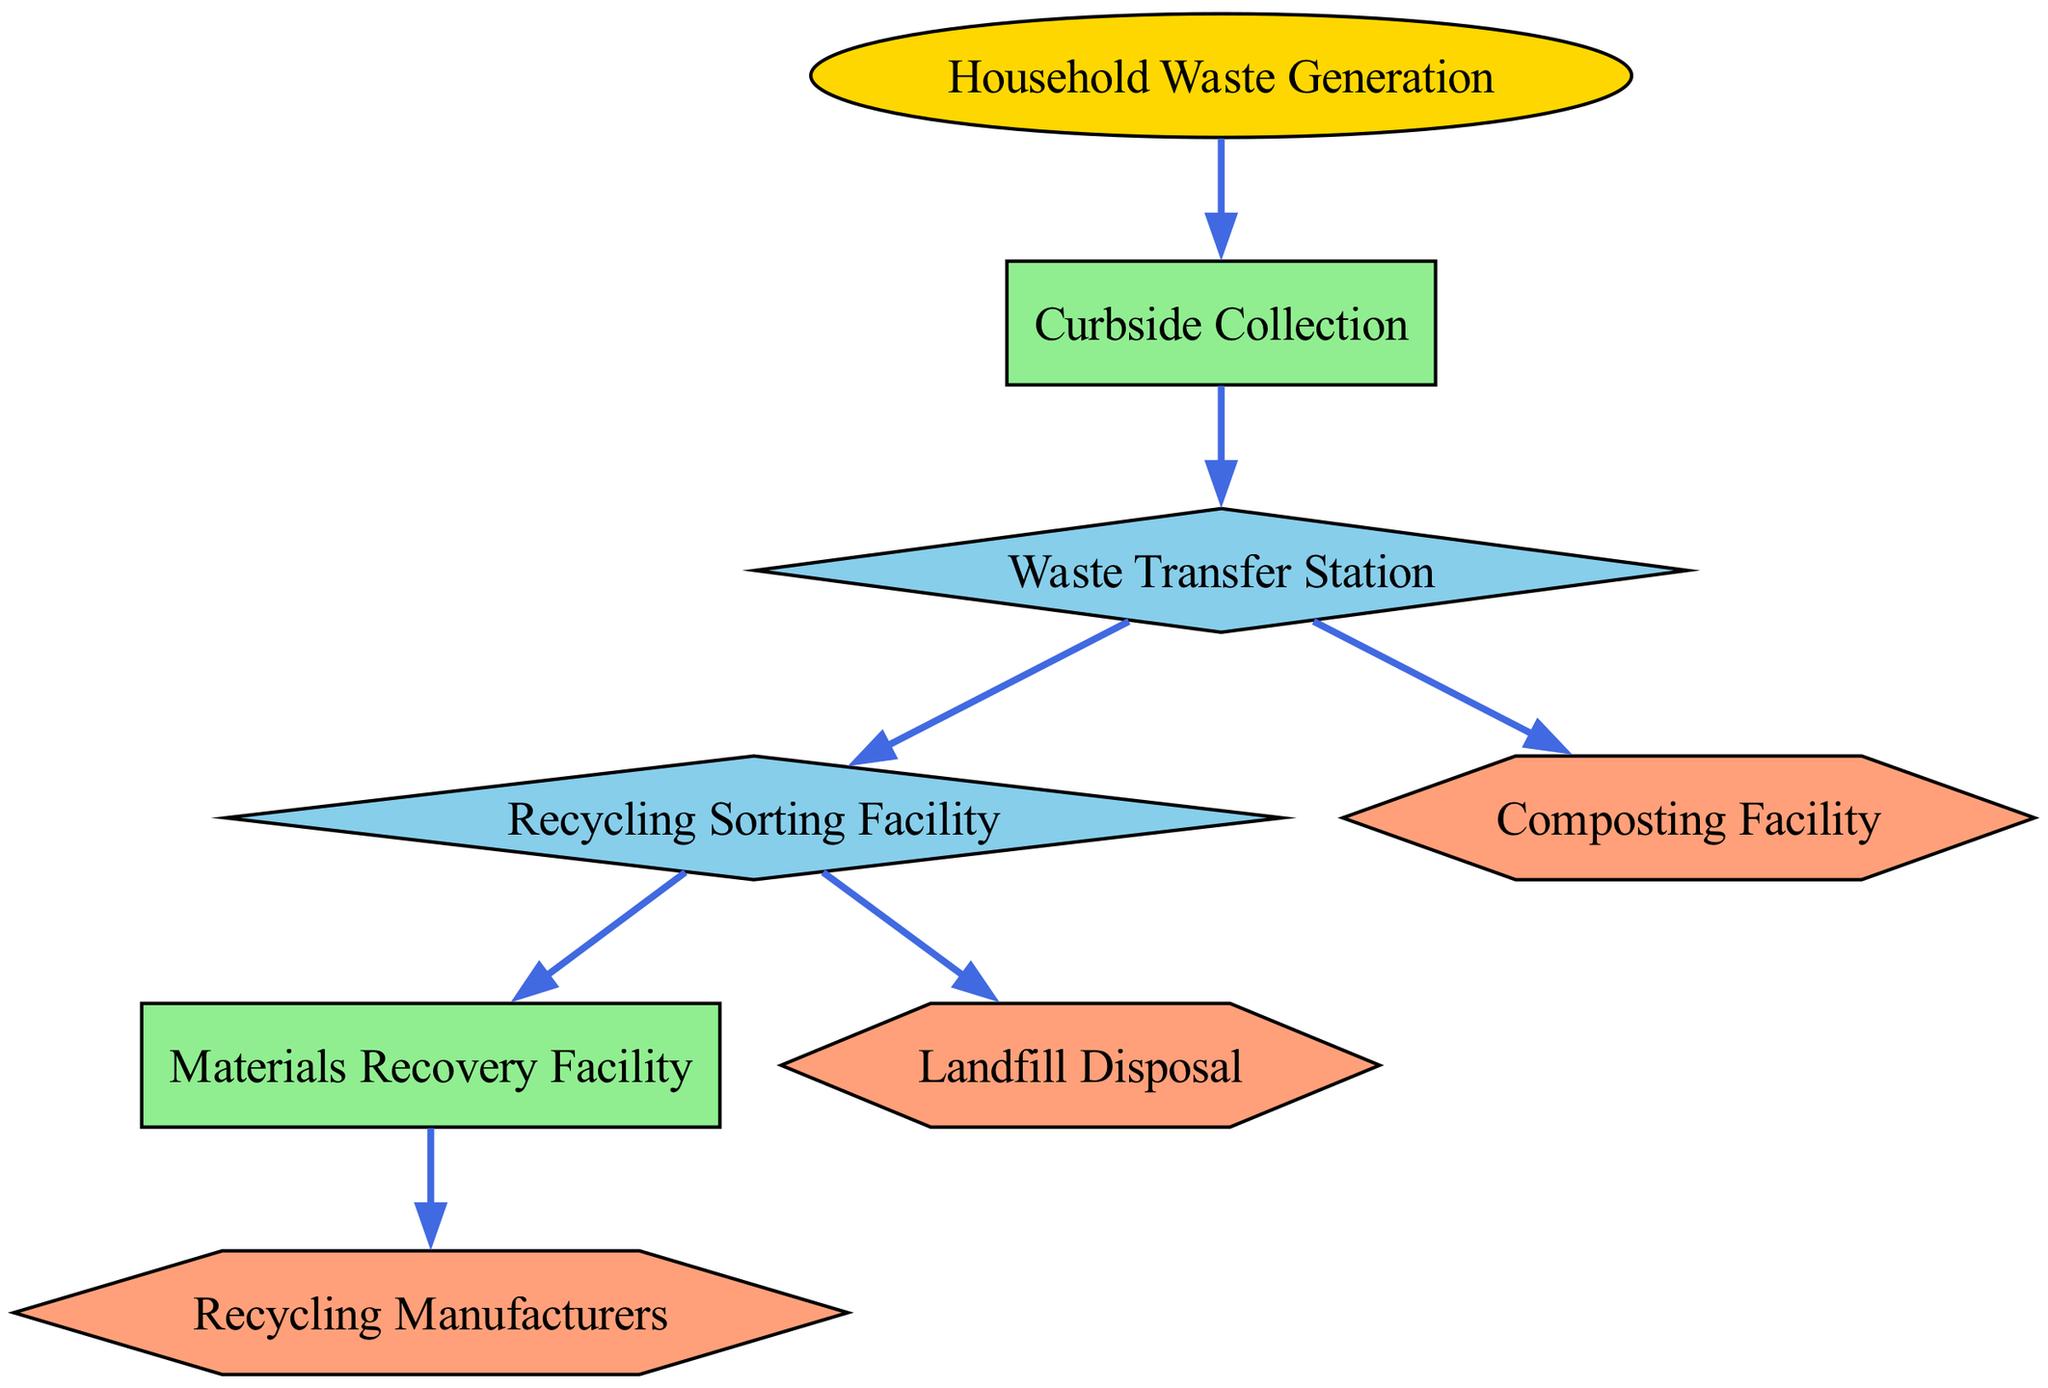What is the first step in the waste management process? The diagram starts with "Household Waste Generation" as the initial node, indicating it is the first step in the process flow of waste management.
Answer: Household Waste Generation How many nodes represent a process in the diagram? There are three nodes that represent processes: "Curbside Collection," "Materials Recovery Facility," and "Recycling Sorting Facility." By counting these specific labels, we arrive at the total.
Answer: 3 What is the final destination for non-recyclable waste? The diagram indicates "Landfill Disposal" as the endpoint for non-recyclable waste materials, identified clearly as a destination node.
Answer: Landfill Disposal Which facility handles organic waste? The diagram shows that the "Composting Facility" is specifically designated for handling organic waste, making it the key location for this process.
Answer: Composting Facility What happens to recyclables after the Recycling Sorting Facility? After the "Recycling Sorting Facility," materials are sent to the "Materials Recovery Facility" for further sorting before they reach recycling manufacturers. This flow can be traced directly through the diagram connections.
Answer: Materials Recovery Facility How many edges connect the "Waste Transfer Station" to other nodes? The "Waste Transfer Station" connects to three other nodes: "Recycling Sorting Facility," "Composting Facility," and "Landfill Disposal." By reviewing the connections, it's evident that it has multiple outgoing edges.
Answer: 3 Which type of node is "Recycling Manufacturers"? The "Recycling Manufacturers" is classified as a destination, as indicated by its hexagon shape and description in the diagram. This classification can be confirmed directly from the node properties.
Answer: Destination From the "Waste Transfer Station," what two processes can occur? The two processes following the "Waste Transfer Station" are either being sent to the "Recycling Sorting Facility" or being disposed of in "Landfill Disposal," both of which are dictated by the connections visible in the diagram.
Answer: Recycling Sorting Facility and Landfill Disposal What color represents process nodes in the diagram? Process nodes are illustrated in light green, as specified in the node styles section of the diagram specifications. This distinct color coding allows for easy identification of each type.
Answer: Light green 